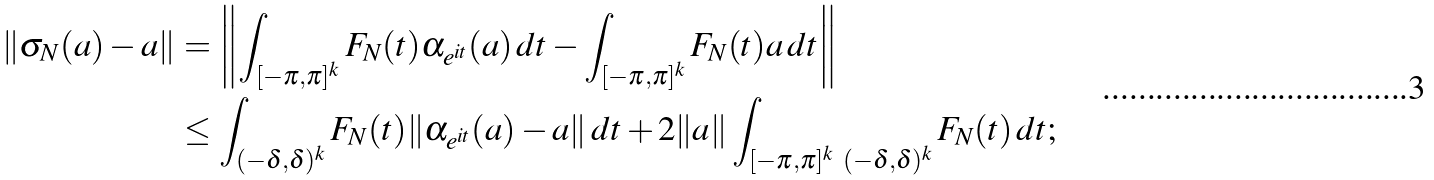Convert formula to latex. <formula><loc_0><loc_0><loc_500><loc_500>\| \sigma _ { N } ( a ) - a \| & = \left \| \int _ { [ - \pi , \pi ] ^ { k } } F _ { N } ( t ) \alpha _ { e ^ { i t } } ( a ) \, d t - \int _ { [ - \pi , \pi ] ^ { k } } F _ { N } ( t ) a \, d t \right \| \\ & \leq \int _ { ( - \delta , \delta ) ^ { k } } F _ { N } ( t ) \| \alpha _ { e ^ { i t } } ( a ) - a \| \, d t + 2 \| a \| \int _ { [ - \pi , \pi ] ^ { k } \ ( - \delta , \delta ) ^ { k } } F _ { N } ( t ) \, d t ;</formula> 